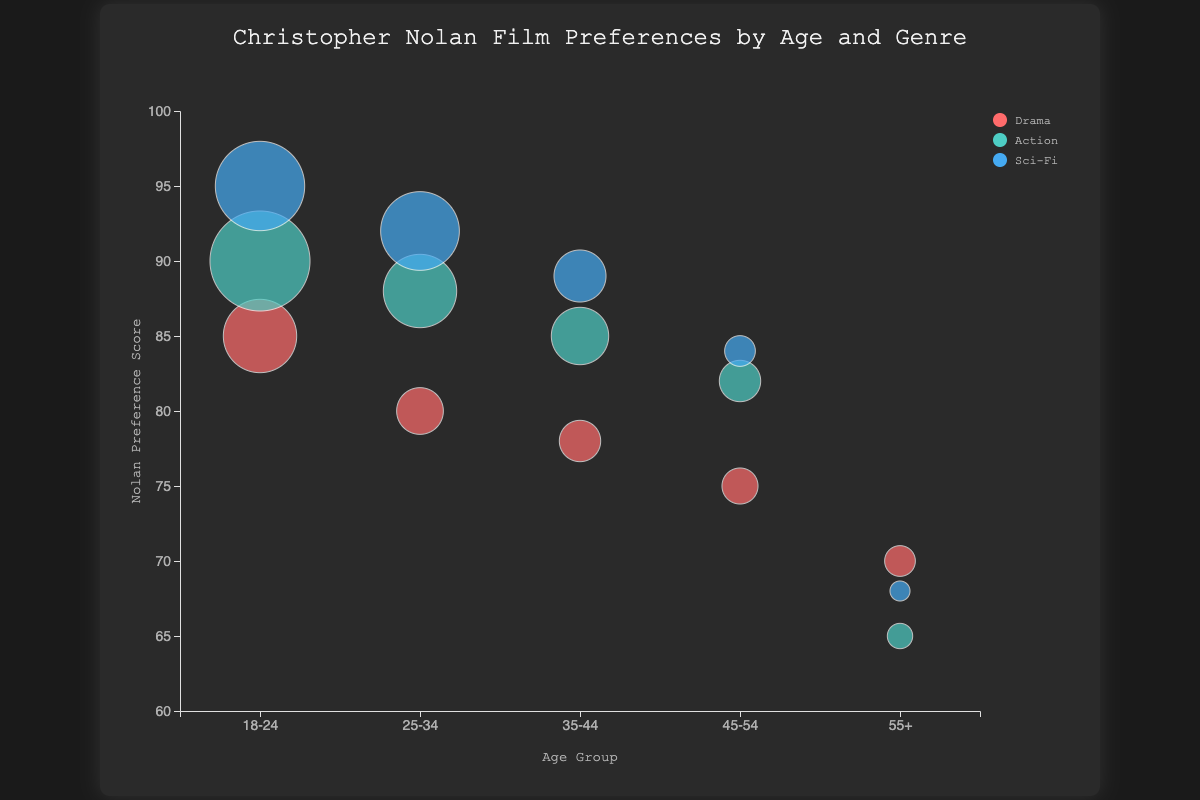What is the highest Nolan preference score among the 18-24 age group? The Nolan preference score for the 18-24 age group can be identified for each genre: Drama is 85, Action is 90, and Sci-Fi is 95. The highest score is 95.
Answer: 95 Which age group has the smallest watch count for Sci-Fi movies? The data points show the following watch counts for Sci-Fi movies: 18-24 (180), 25-34 (160), 35-44 (110), 45-54 (70), 55+ (50). The smallest watch count is 50 from the 55+ age group.
Answer: 55+ What is the title of the plot? The title is written at the top of the plot. It reads "Christopher Nolan Film Preferences by Age and Genre."
Answer: Christopher Nolan Film Preferences by Age and Genre How many different genres are represented in the plot? Looking at the legend on the plot, there are three different genres represented: Drama, Action, and Sci-Fi.
Answer: 3 Compare the Nolan preference scores for Drama between the 25-34 and 35-44 age groups. Which is higher? For the 25-34 age group, the score is 80; for the 35-44 age group, it is 78. Hence, the 25-34 age group has a higher score.
Answer: 25-34 What is the average Nolan preference score for all age groups in the Sci-Fi genre? The Nolan preference scores for Sci-Fi across the age groups are 95, 92, 89, 84, and 68. Adding these gives a total of 428. Dividing by 5 (number of age groups), the average is 428 / 5 = 85.6
Answer: 85.6 Which genre in the 45-54 age group has the highest Nolan preference score? Within the 45-54 age group, the preference scores are Drama (75), Action (82), and Sci-Fi (84). The highest score is for Sci-Fi at 84.
Answer: Sci-Fi Is the Nolan preference score higher for Drama or Action in the 18-24 age group? In the 18-24 age group, the preference scores are 85 for Drama and 90 for Action. Thus, the score for Action is higher.
Answer: Action What's the overall trend in watch count for Drama genre as the age group increases? Observing the sizes of the bubbles for Drama across age groups (18-24: 150, 25-34: 100, 35-44: 90, 45-54: 80, 55+: 70), there is a decreasing trend in watch count as the age group increases.
Answer: Decreasing How does the preference score change for Action movies between the 35-44 and 45-54 age groups? The preference score for Action movies in the 35-44 age group is 85, and in the 45-54 age group, it is 82. The score decreases as the age group increases.
Answer: Decreases 